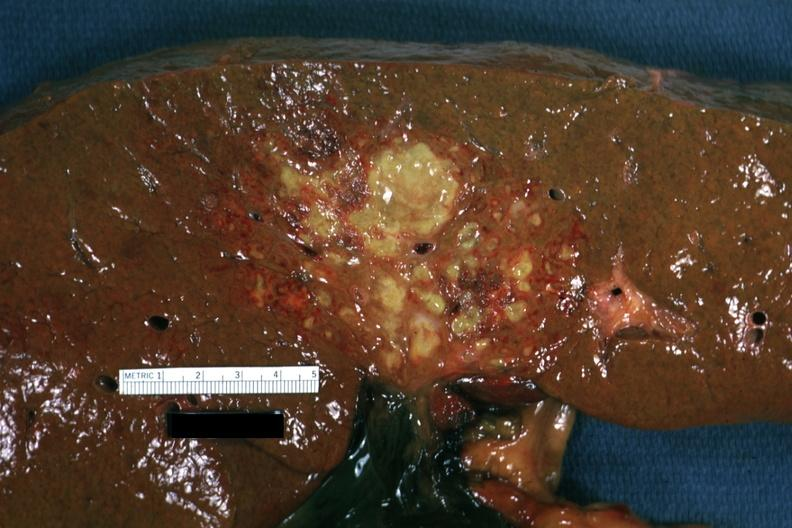what does this look?
Answer the question using a single word or phrase. Like an ascending cholangitis 